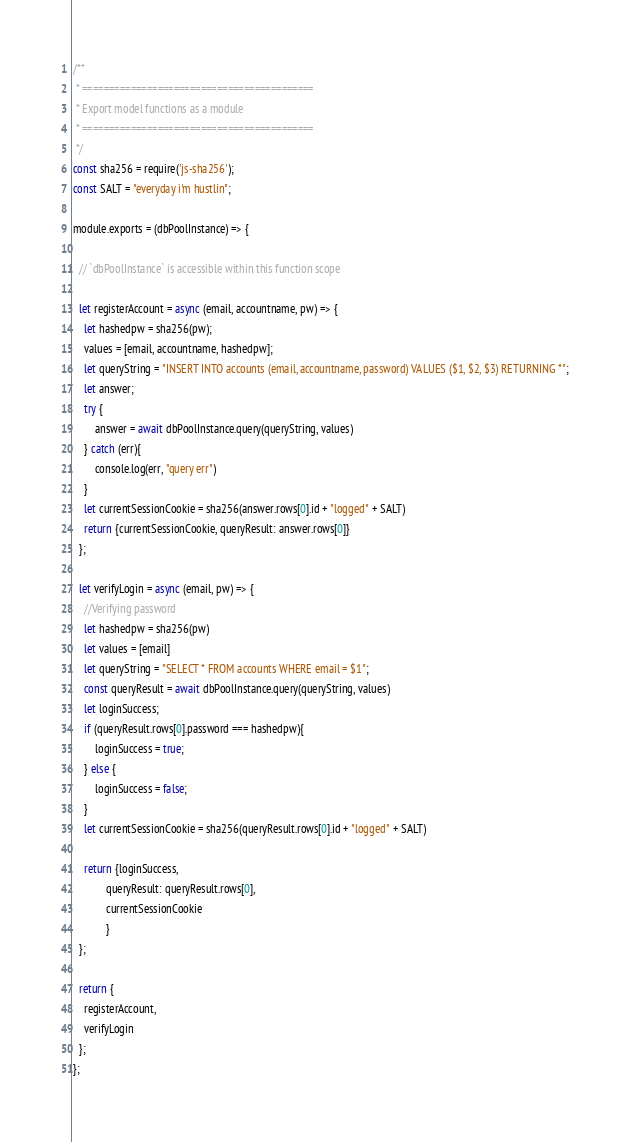<code> <loc_0><loc_0><loc_500><loc_500><_JavaScript_>/**
 * ===========================================
 * Export model functions as a module
 * ===========================================
 */
const sha256 = require('js-sha256');
const SALT = "everyday i'm hustlin";

module.exports = (dbPoolInstance) => {

  // `dbPoolInstance` is accessible within this function scope

  let registerAccount = async (email, accountname, pw) => {
    let hashedpw = sha256(pw);
    values = [email, accountname, hashedpw];
    let queryString = "INSERT INTO accounts (email, accountname, password) VALUES ($1, $2, $3) RETURNING *";
    let answer;
    try {
        answer = await dbPoolInstance.query(queryString, values)
    } catch (err){
        console.log(err, "query err")
    }
    let currentSessionCookie = sha256(answer.rows[0].id + "logged" + SALT)
    return {currentSessionCookie, queryResult: answer.rows[0]}
  };

  let verifyLogin = async (email, pw) => {
    //Verifying password
    let hashedpw = sha256(pw)
    let values = [email]
    let queryString = "SELECT * FROM accounts WHERE email = $1";
    const queryResult = await dbPoolInstance.query(queryString, values)
    let loginSuccess;
    if (queryResult.rows[0].password === hashedpw){
        loginSuccess = true;
    } else {
        loginSuccess = false;
    }
    let currentSessionCookie = sha256(queryResult.rows[0].id + "logged" + SALT)

    return {loginSuccess,
            queryResult: queryResult.rows[0],
            currentSessionCookie
            }
  };

  return {
    registerAccount,
    verifyLogin
  };
};</code> 